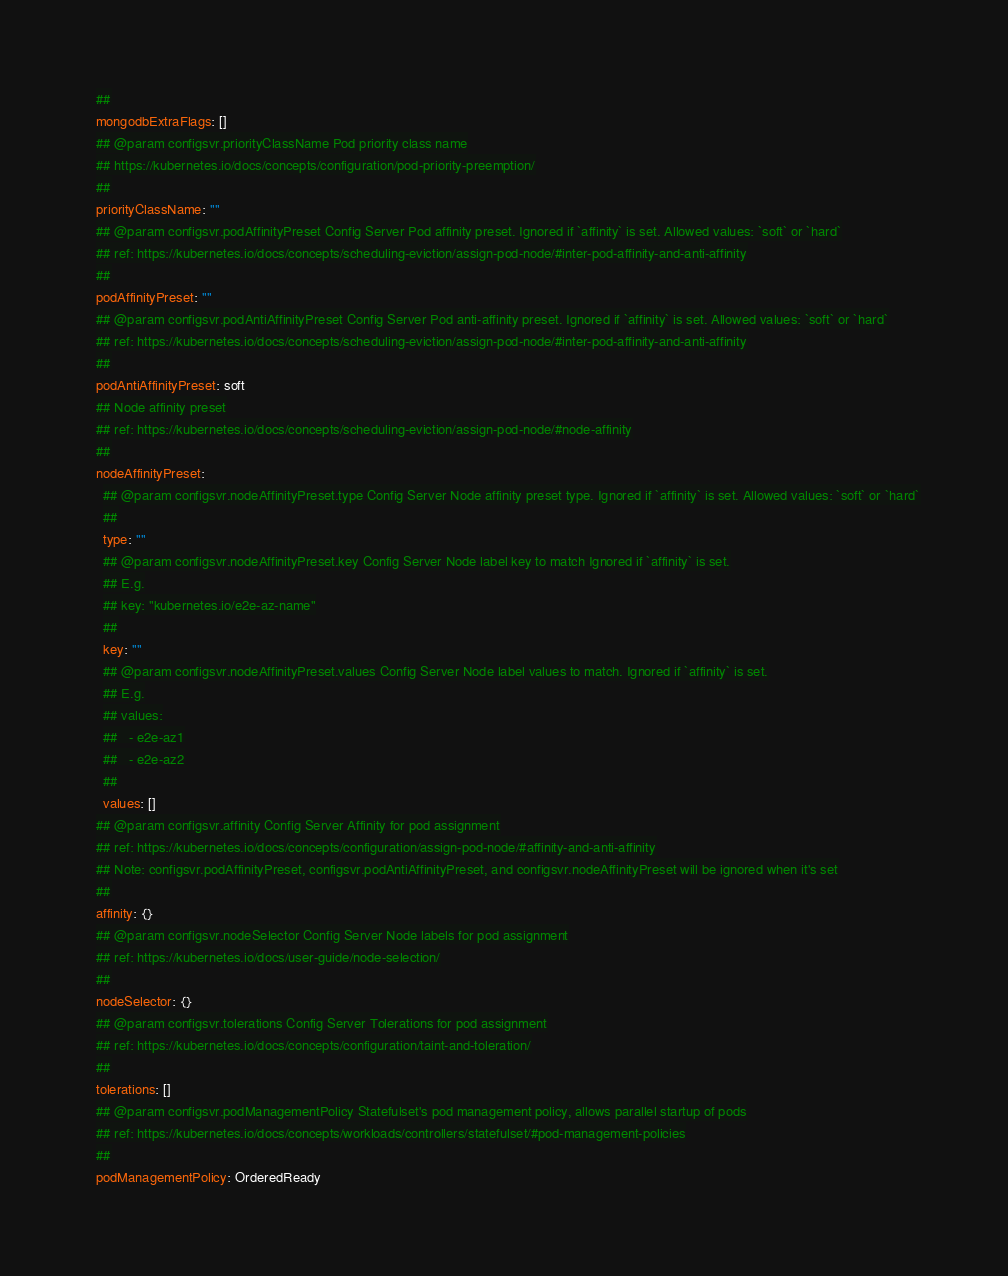Convert code to text. <code><loc_0><loc_0><loc_500><loc_500><_YAML_>  ##
  mongodbExtraFlags: []
  ## @param configsvr.priorityClassName Pod priority class name
  ## https://kubernetes.io/docs/concepts/configuration/pod-priority-preemption/
  ##
  priorityClassName: ""
  ## @param configsvr.podAffinityPreset Config Server Pod affinity preset. Ignored if `affinity` is set. Allowed values: `soft` or `hard`
  ## ref: https://kubernetes.io/docs/concepts/scheduling-eviction/assign-pod-node/#inter-pod-affinity-and-anti-affinity
  ##
  podAffinityPreset: ""
  ## @param configsvr.podAntiAffinityPreset Config Server Pod anti-affinity preset. Ignored if `affinity` is set. Allowed values: `soft` or `hard`
  ## ref: https://kubernetes.io/docs/concepts/scheduling-eviction/assign-pod-node/#inter-pod-affinity-and-anti-affinity
  ##
  podAntiAffinityPreset: soft
  ## Node affinity preset
  ## ref: https://kubernetes.io/docs/concepts/scheduling-eviction/assign-pod-node/#node-affinity
  ##
  nodeAffinityPreset:
    ## @param configsvr.nodeAffinityPreset.type Config Server Node affinity preset type. Ignored if `affinity` is set. Allowed values: `soft` or `hard`
    ##
    type: ""
    ## @param configsvr.nodeAffinityPreset.key Config Server Node label key to match Ignored if `affinity` is set.
    ## E.g.
    ## key: "kubernetes.io/e2e-az-name"
    ##
    key: ""
    ## @param configsvr.nodeAffinityPreset.values Config Server Node label values to match. Ignored if `affinity` is set.
    ## E.g.
    ## values:
    ##   - e2e-az1
    ##   - e2e-az2
    ##
    values: []
  ## @param configsvr.affinity Config Server Affinity for pod assignment
  ## ref: https://kubernetes.io/docs/concepts/configuration/assign-pod-node/#affinity-and-anti-affinity
  ## Note: configsvr.podAffinityPreset, configsvr.podAntiAffinityPreset, and configsvr.nodeAffinityPreset will be ignored when it's set
  ##
  affinity: {}
  ## @param configsvr.nodeSelector Config Server Node labels for pod assignment
  ## ref: https://kubernetes.io/docs/user-guide/node-selection/
  ##
  nodeSelector: {}
  ## @param configsvr.tolerations Config Server Tolerations for pod assignment
  ## ref: https://kubernetes.io/docs/concepts/configuration/taint-and-toleration/
  ##
  tolerations: []
  ## @param configsvr.podManagementPolicy Statefulset's pod management policy, allows parallel startup of pods
  ## ref: https://kubernetes.io/docs/concepts/workloads/controllers/statefulset/#pod-management-policies
  ##
  podManagementPolicy: OrderedReady</code> 